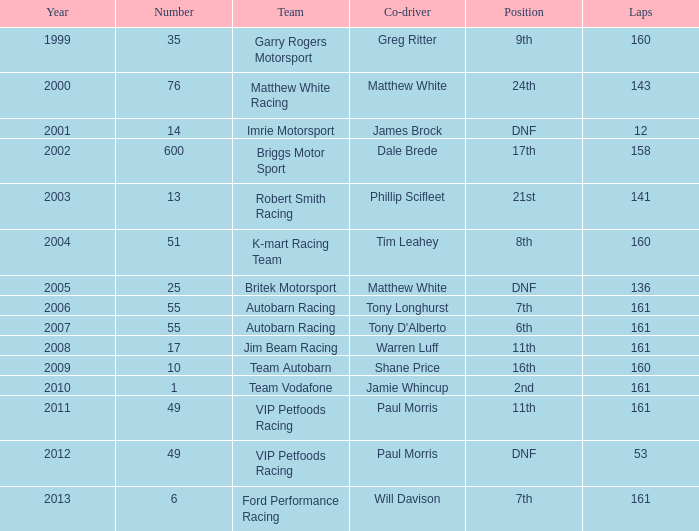What is the fewest laps for a team with a position of DNF and a number smaller than 25 before 2001? None. 